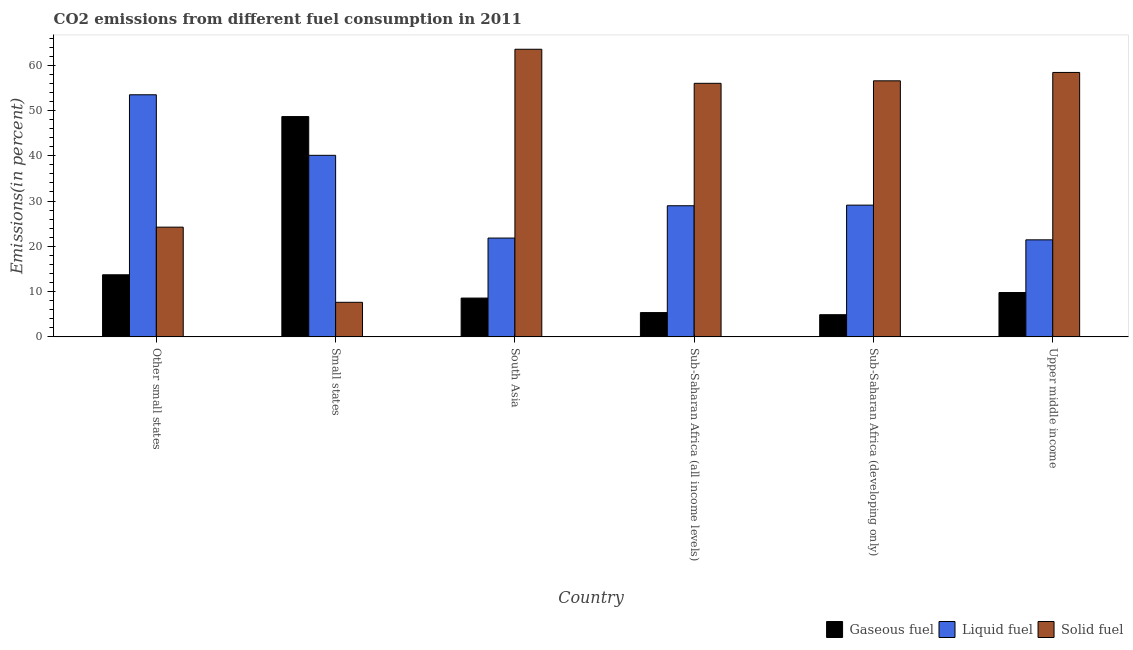How many groups of bars are there?
Your answer should be very brief. 6. Are the number of bars per tick equal to the number of legend labels?
Ensure brevity in your answer.  Yes. What is the label of the 5th group of bars from the left?
Offer a very short reply. Sub-Saharan Africa (developing only). In how many cases, is the number of bars for a given country not equal to the number of legend labels?
Make the answer very short. 0. What is the percentage of solid fuel emission in Small states?
Your answer should be very brief. 7.64. Across all countries, what is the maximum percentage of gaseous fuel emission?
Ensure brevity in your answer.  48.66. Across all countries, what is the minimum percentage of gaseous fuel emission?
Offer a very short reply. 4.9. In which country was the percentage of liquid fuel emission maximum?
Your answer should be compact. Other small states. In which country was the percentage of liquid fuel emission minimum?
Provide a short and direct response. Upper middle income. What is the total percentage of solid fuel emission in the graph?
Your answer should be very brief. 266.35. What is the difference between the percentage of gaseous fuel emission in Small states and that in Upper middle income?
Ensure brevity in your answer.  38.86. What is the difference between the percentage of gaseous fuel emission in Small states and the percentage of liquid fuel emission in South Asia?
Provide a succinct answer. 26.83. What is the average percentage of liquid fuel emission per country?
Offer a very short reply. 32.48. What is the difference between the percentage of gaseous fuel emission and percentage of solid fuel emission in Sub-Saharan Africa (all income levels)?
Keep it short and to the point. -50.63. In how many countries, is the percentage of solid fuel emission greater than 24 %?
Ensure brevity in your answer.  5. What is the ratio of the percentage of solid fuel emission in Other small states to that in South Asia?
Your response must be concise. 0.38. Is the percentage of gaseous fuel emission in Small states less than that in Upper middle income?
Offer a very short reply. No. What is the difference between the highest and the second highest percentage of gaseous fuel emission?
Make the answer very short. 34.95. What is the difference between the highest and the lowest percentage of liquid fuel emission?
Make the answer very short. 32.04. In how many countries, is the percentage of solid fuel emission greater than the average percentage of solid fuel emission taken over all countries?
Your response must be concise. 4. Is the sum of the percentage of gaseous fuel emission in South Asia and Upper middle income greater than the maximum percentage of liquid fuel emission across all countries?
Provide a succinct answer. No. What does the 3rd bar from the left in South Asia represents?
Your answer should be very brief. Solid fuel. What does the 1st bar from the right in Upper middle income represents?
Your response must be concise. Solid fuel. Is it the case that in every country, the sum of the percentage of gaseous fuel emission and percentage of liquid fuel emission is greater than the percentage of solid fuel emission?
Make the answer very short. No. How many bars are there?
Your response must be concise. 18. How many countries are there in the graph?
Your response must be concise. 6. What is the difference between two consecutive major ticks on the Y-axis?
Your response must be concise. 10. Are the values on the major ticks of Y-axis written in scientific E-notation?
Offer a terse response. No. Where does the legend appear in the graph?
Provide a succinct answer. Bottom right. How many legend labels are there?
Offer a terse response. 3. What is the title of the graph?
Your answer should be very brief. CO2 emissions from different fuel consumption in 2011. What is the label or title of the X-axis?
Your response must be concise. Country. What is the label or title of the Y-axis?
Your answer should be compact. Emissions(in percent). What is the Emissions(in percent) of Gaseous fuel in Other small states?
Ensure brevity in your answer.  13.71. What is the Emissions(in percent) in Liquid fuel in Other small states?
Your response must be concise. 53.47. What is the Emissions(in percent) in Solid fuel in Other small states?
Make the answer very short. 24.24. What is the Emissions(in percent) of Gaseous fuel in Small states?
Make the answer very short. 48.66. What is the Emissions(in percent) of Liquid fuel in Small states?
Your answer should be very brief. 40.1. What is the Emissions(in percent) in Solid fuel in Small states?
Provide a succinct answer. 7.64. What is the Emissions(in percent) of Gaseous fuel in South Asia?
Keep it short and to the point. 8.57. What is the Emissions(in percent) in Liquid fuel in South Asia?
Provide a succinct answer. 21.82. What is the Emissions(in percent) of Solid fuel in South Asia?
Make the answer very short. 63.53. What is the Emissions(in percent) of Gaseous fuel in Sub-Saharan Africa (all income levels)?
Make the answer very short. 5.37. What is the Emissions(in percent) in Liquid fuel in Sub-Saharan Africa (all income levels)?
Make the answer very short. 28.96. What is the Emissions(in percent) in Solid fuel in Sub-Saharan Africa (all income levels)?
Offer a very short reply. 56. What is the Emissions(in percent) in Gaseous fuel in Sub-Saharan Africa (developing only)?
Provide a short and direct response. 4.9. What is the Emissions(in percent) in Liquid fuel in Sub-Saharan Africa (developing only)?
Provide a succinct answer. 29.1. What is the Emissions(in percent) in Solid fuel in Sub-Saharan Africa (developing only)?
Your answer should be compact. 56.55. What is the Emissions(in percent) of Gaseous fuel in Upper middle income?
Offer a very short reply. 9.8. What is the Emissions(in percent) of Liquid fuel in Upper middle income?
Provide a short and direct response. 21.43. What is the Emissions(in percent) in Solid fuel in Upper middle income?
Give a very brief answer. 58.4. Across all countries, what is the maximum Emissions(in percent) of Gaseous fuel?
Make the answer very short. 48.66. Across all countries, what is the maximum Emissions(in percent) of Liquid fuel?
Your response must be concise. 53.47. Across all countries, what is the maximum Emissions(in percent) in Solid fuel?
Your answer should be compact. 63.53. Across all countries, what is the minimum Emissions(in percent) of Gaseous fuel?
Offer a very short reply. 4.9. Across all countries, what is the minimum Emissions(in percent) of Liquid fuel?
Your answer should be very brief. 21.43. Across all countries, what is the minimum Emissions(in percent) of Solid fuel?
Give a very brief answer. 7.64. What is the total Emissions(in percent) in Gaseous fuel in the graph?
Your response must be concise. 91. What is the total Emissions(in percent) of Liquid fuel in the graph?
Your response must be concise. 194.88. What is the total Emissions(in percent) of Solid fuel in the graph?
Your answer should be compact. 266.35. What is the difference between the Emissions(in percent) of Gaseous fuel in Other small states and that in Small states?
Your answer should be compact. -34.95. What is the difference between the Emissions(in percent) in Liquid fuel in Other small states and that in Small states?
Provide a succinct answer. 13.37. What is the difference between the Emissions(in percent) of Solid fuel in Other small states and that in Small states?
Make the answer very short. 16.6. What is the difference between the Emissions(in percent) of Gaseous fuel in Other small states and that in South Asia?
Your response must be concise. 5.14. What is the difference between the Emissions(in percent) in Liquid fuel in Other small states and that in South Asia?
Keep it short and to the point. 31.65. What is the difference between the Emissions(in percent) in Solid fuel in Other small states and that in South Asia?
Your answer should be compact. -39.29. What is the difference between the Emissions(in percent) of Gaseous fuel in Other small states and that in Sub-Saharan Africa (all income levels)?
Ensure brevity in your answer.  8.34. What is the difference between the Emissions(in percent) in Liquid fuel in Other small states and that in Sub-Saharan Africa (all income levels)?
Provide a short and direct response. 24.51. What is the difference between the Emissions(in percent) of Solid fuel in Other small states and that in Sub-Saharan Africa (all income levels)?
Your answer should be very brief. -31.77. What is the difference between the Emissions(in percent) of Gaseous fuel in Other small states and that in Sub-Saharan Africa (developing only)?
Provide a succinct answer. 8.82. What is the difference between the Emissions(in percent) of Liquid fuel in Other small states and that in Sub-Saharan Africa (developing only)?
Give a very brief answer. 24.38. What is the difference between the Emissions(in percent) in Solid fuel in Other small states and that in Sub-Saharan Africa (developing only)?
Offer a very short reply. -32.32. What is the difference between the Emissions(in percent) of Gaseous fuel in Other small states and that in Upper middle income?
Provide a short and direct response. 3.92. What is the difference between the Emissions(in percent) in Liquid fuel in Other small states and that in Upper middle income?
Provide a succinct answer. 32.04. What is the difference between the Emissions(in percent) in Solid fuel in Other small states and that in Upper middle income?
Your response must be concise. -34.17. What is the difference between the Emissions(in percent) in Gaseous fuel in Small states and that in South Asia?
Your response must be concise. 40.09. What is the difference between the Emissions(in percent) in Liquid fuel in Small states and that in South Asia?
Offer a terse response. 18.27. What is the difference between the Emissions(in percent) of Solid fuel in Small states and that in South Asia?
Offer a terse response. -55.89. What is the difference between the Emissions(in percent) in Gaseous fuel in Small states and that in Sub-Saharan Africa (all income levels)?
Your answer should be very brief. 43.29. What is the difference between the Emissions(in percent) of Liquid fuel in Small states and that in Sub-Saharan Africa (all income levels)?
Provide a succinct answer. 11.14. What is the difference between the Emissions(in percent) of Solid fuel in Small states and that in Sub-Saharan Africa (all income levels)?
Offer a very short reply. -48.37. What is the difference between the Emissions(in percent) in Gaseous fuel in Small states and that in Sub-Saharan Africa (developing only)?
Ensure brevity in your answer.  43.76. What is the difference between the Emissions(in percent) of Liquid fuel in Small states and that in Sub-Saharan Africa (developing only)?
Provide a short and direct response. 11. What is the difference between the Emissions(in percent) in Solid fuel in Small states and that in Sub-Saharan Africa (developing only)?
Offer a terse response. -48.92. What is the difference between the Emissions(in percent) of Gaseous fuel in Small states and that in Upper middle income?
Your answer should be compact. 38.86. What is the difference between the Emissions(in percent) in Liquid fuel in Small states and that in Upper middle income?
Offer a terse response. 18.67. What is the difference between the Emissions(in percent) of Solid fuel in Small states and that in Upper middle income?
Your response must be concise. -50.77. What is the difference between the Emissions(in percent) of Gaseous fuel in South Asia and that in Sub-Saharan Africa (all income levels)?
Provide a succinct answer. 3.2. What is the difference between the Emissions(in percent) of Liquid fuel in South Asia and that in Sub-Saharan Africa (all income levels)?
Keep it short and to the point. -7.14. What is the difference between the Emissions(in percent) in Solid fuel in South Asia and that in Sub-Saharan Africa (all income levels)?
Your answer should be very brief. 7.52. What is the difference between the Emissions(in percent) of Gaseous fuel in South Asia and that in Sub-Saharan Africa (developing only)?
Your response must be concise. 3.67. What is the difference between the Emissions(in percent) in Liquid fuel in South Asia and that in Sub-Saharan Africa (developing only)?
Provide a succinct answer. -7.27. What is the difference between the Emissions(in percent) of Solid fuel in South Asia and that in Sub-Saharan Africa (developing only)?
Your answer should be very brief. 6.97. What is the difference between the Emissions(in percent) of Gaseous fuel in South Asia and that in Upper middle income?
Keep it short and to the point. -1.23. What is the difference between the Emissions(in percent) of Liquid fuel in South Asia and that in Upper middle income?
Offer a terse response. 0.39. What is the difference between the Emissions(in percent) of Solid fuel in South Asia and that in Upper middle income?
Make the answer very short. 5.12. What is the difference between the Emissions(in percent) in Gaseous fuel in Sub-Saharan Africa (all income levels) and that in Sub-Saharan Africa (developing only)?
Keep it short and to the point. 0.47. What is the difference between the Emissions(in percent) of Liquid fuel in Sub-Saharan Africa (all income levels) and that in Sub-Saharan Africa (developing only)?
Provide a succinct answer. -0.13. What is the difference between the Emissions(in percent) in Solid fuel in Sub-Saharan Africa (all income levels) and that in Sub-Saharan Africa (developing only)?
Your answer should be very brief. -0.55. What is the difference between the Emissions(in percent) of Gaseous fuel in Sub-Saharan Africa (all income levels) and that in Upper middle income?
Make the answer very short. -4.43. What is the difference between the Emissions(in percent) in Liquid fuel in Sub-Saharan Africa (all income levels) and that in Upper middle income?
Offer a very short reply. 7.53. What is the difference between the Emissions(in percent) in Solid fuel in Sub-Saharan Africa (all income levels) and that in Upper middle income?
Your answer should be compact. -2.4. What is the difference between the Emissions(in percent) in Gaseous fuel in Sub-Saharan Africa (developing only) and that in Upper middle income?
Ensure brevity in your answer.  -4.9. What is the difference between the Emissions(in percent) in Liquid fuel in Sub-Saharan Africa (developing only) and that in Upper middle income?
Your answer should be very brief. 7.66. What is the difference between the Emissions(in percent) of Solid fuel in Sub-Saharan Africa (developing only) and that in Upper middle income?
Offer a terse response. -1.85. What is the difference between the Emissions(in percent) in Gaseous fuel in Other small states and the Emissions(in percent) in Liquid fuel in Small states?
Offer a terse response. -26.39. What is the difference between the Emissions(in percent) in Gaseous fuel in Other small states and the Emissions(in percent) in Solid fuel in Small states?
Make the answer very short. 6.08. What is the difference between the Emissions(in percent) of Liquid fuel in Other small states and the Emissions(in percent) of Solid fuel in Small states?
Ensure brevity in your answer.  45.84. What is the difference between the Emissions(in percent) of Gaseous fuel in Other small states and the Emissions(in percent) of Liquid fuel in South Asia?
Your answer should be compact. -8.11. What is the difference between the Emissions(in percent) of Gaseous fuel in Other small states and the Emissions(in percent) of Solid fuel in South Asia?
Provide a short and direct response. -49.81. What is the difference between the Emissions(in percent) in Liquid fuel in Other small states and the Emissions(in percent) in Solid fuel in South Asia?
Provide a succinct answer. -10.05. What is the difference between the Emissions(in percent) of Gaseous fuel in Other small states and the Emissions(in percent) of Liquid fuel in Sub-Saharan Africa (all income levels)?
Your answer should be very brief. -15.25. What is the difference between the Emissions(in percent) of Gaseous fuel in Other small states and the Emissions(in percent) of Solid fuel in Sub-Saharan Africa (all income levels)?
Offer a terse response. -42.29. What is the difference between the Emissions(in percent) in Liquid fuel in Other small states and the Emissions(in percent) in Solid fuel in Sub-Saharan Africa (all income levels)?
Your answer should be very brief. -2.53. What is the difference between the Emissions(in percent) of Gaseous fuel in Other small states and the Emissions(in percent) of Liquid fuel in Sub-Saharan Africa (developing only)?
Your answer should be very brief. -15.38. What is the difference between the Emissions(in percent) of Gaseous fuel in Other small states and the Emissions(in percent) of Solid fuel in Sub-Saharan Africa (developing only)?
Provide a succinct answer. -42.84. What is the difference between the Emissions(in percent) in Liquid fuel in Other small states and the Emissions(in percent) in Solid fuel in Sub-Saharan Africa (developing only)?
Give a very brief answer. -3.08. What is the difference between the Emissions(in percent) of Gaseous fuel in Other small states and the Emissions(in percent) of Liquid fuel in Upper middle income?
Provide a short and direct response. -7.72. What is the difference between the Emissions(in percent) of Gaseous fuel in Other small states and the Emissions(in percent) of Solid fuel in Upper middle income?
Ensure brevity in your answer.  -44.69. What is the difference between the Emissions(in percent) of Liquid fuel in Other small states and the Emissions(in percent) of Solid fuel in Upper middle income?
Give a very brief answer. -4.93. What is the difference between the Emissions(in percent) in Gaseous fuel in Small states and the Emissions(in percent) in Liquid fuel in South Asia?
Ensure brevity in your answer.  26.83. What is the difference between the Emissions(in percent) of Gaseous fuel in Small states and the Emissions(in percent) of Solid fuel in South Asia?
Keep it short and to the point. -14.87. What is the difference between the Emissions(in percent) of Liquid fuel in Small states and the Emissions(in percent) of Solid fuel in South Asia?
Offer a very short reply. -23.43. What is the difference between the Emissions(in percent) of Gaseous fuel in Small states and the Emissions(in percent) of Liquid fuel in Sub-Saharan Africa (all income levels)?
Offer a very short reply. 19.7. What is the difference between the Emissions(in percent) of Gaseous fuel in Small states and the Emissions(in percent) of Solid fuel in Sub-Saharan Africa (all income levels)?
Provide a succinct answer. -7.34. What is the difference between the Emissions(in percent) of Liquid fuel in Small states and the Emissions(in percent) of Solid fuel in Sub-Saharan Africa (all income levels)?
Provide a succinct answer. -15.9. What is the difference between the Emissions(in percent) of Gaseous fuel in Small states and the Emissions(in percent) of Liquid fuel in Sub-Saharan Africa (developing only)?
Your answer should be very brief. 19.56. What is the difference between the Emissions(in percent) in Gaseous fuel in Small states and the Emissions(in percent) in Solid fuel in Sub-Saharan Africa (developing only)?
Your answer should be compact. -7.89. What is the difference between the Emissions(in percent) in Liquid fuel in Small states and the Emissions(in percent) in Solid fuel in Sub-Saharan Africa (developing only)?
Provide a succinct answer. -16.45. What is the difference between the Emissions(in percent) of Gaseous fuel in Small states and the Emissions(in percent) of Liquid fuel in Upper middle income?
Make the answer very short. 27.23. What is the difference between the Emissions(in percent) in Gaseous fuel in Small states and the Emissions(in percent) in Solid fuel in Upper middle income?
Offer a terse response. -9.74. What is the difference between the Emissions(in percent) in Liquid fuel in Small states and the Emissions(in percent) in Solid fuel in Upper middle income?
Give a very brief answer. -18.3. What is the difference between the Emissions(in percent) of Gaseous fuel in South Asia and the Emissions(in percent) of Liquid fuel in Sub-Saharan Africa (all income levels)?
Keep it short and to the point. -20.39. What is the difference between the Emissions(in percent) of Gaseous fuel in South Asia and the Emissions(in percent) of Solid fuel in Sub-Saharan Africa (all income levels)?
Offer a very short reply. -47.43. What is the difference between the Emissions(in percent) of Liquid fuel in South Asia and the Emissions(in percent) of Solid fuel in Sub-Saharan Africa (all income levels)?
Offer a terse response. -34.18. What is the difference between the Emissions(in percent) in Gaseous fuel in South Asia and the Emissions(in percent) in Liquid fuel in Sub-Saharan Africa (developing only)?
Make the answer very short. -20.53. What is the difference between the Emissions(in percent) of Gaseous fuel in South Asia and the Emissions(in percent) of Solid fuel in Sub-Saharan Africa (developing only)?
Offer a terse response. -47.98. What is the difference between the Emissions(in percent) in Liquid fuel in South Asia and the Emissions(in percent) in Solid fuel in Sub-Saharan Africa (developing only)?
Your answer should be compact. -34.73. What is the difference between the Emissions(in percent) of Gaseous fuel in South Asia and the Emissions(in percent) of Liquid fuel in Upper middle income?
Provide a succinct answer. -12.86. What is the difference between the Emissions(in percent) of Gaseous fuel in South Asia and the Emissions(in percent) of Solid fuel in Upper middle income?
Your answer should be very brief. -49.83. What is the difference between the Emissions(in percent) in Liquid fuel in South Asia and the Emissions(in percent) in Solid fuel in Upper middle income?
Provide a short and direct response. -36.58. What is the difference between the Emissions(in percent) of Gaseous fuel in Sub-Saharan Africa (all income levels) and the Emissions(in percent) of Liquid fuel in Sub-Saharan Africa (developing only)?
Offer a very short reply. -23.73. What is the difference between the Emissions(in percent) of Gaseous fuel in Sub-Saharan Africa (all income levels) and the Emissions(in percent) of Solid fuel in Sub-Saharan Africa (developing only)?
Offer a terse response. -51.18. What is the difference between the Emissions(in percent) in Liquid fuel in Sub-Saharan Africa (all income levels) and the Emissions(in percent) in Solid fuel in Sub-Saharan Africa (developing only)?
Offer a very short reply. -27.59. What is the difference between the Emissions(in percent) in Gaseous fuel in Sub-Saharan Africa (all income levels) and the Emissions(in percent) in Liquid fuel in Upper middle income?
Give a very brief answer. -16.06. What is the difference between the Emissions(in percent) of Gaseous fuel in Sub-Saharan Africa (all income levels) and the Emissions(in percent) of Solid fuel in Upper middle income?
Keep it short and to the point. -53.03. What is the difference between the Emissions(in percent) of Liquid fuel in Sub-Saharan Africa (all income levels) and the Emissions(in percent) of Solid fuel in Upper middle income?
Your answer should be very brief. -29.44. What is the difference between the Emissions(in percent) in Gaseous fuel in Sub-Saharan Africa (developing only) and the Emissions(in percent) in Liquid fuel in Upper middle income?
Give a very brief answer. -16.53. What is the difference between the Emissions(in percent) in Gaseous fuel in Sub-Saharan Africa (developing only) and the Emissions(in percent) in Solid fuel in Upper middle income?
Provide a short and direct response. -53.5. What is the difference between the Emissions(in percent) of Liquid fuel in Sub-Saharan Africa (developing only) and the Emissions(in percent) of Solid fuel in Upper middle income?
Offer a terse response. -29.31. What is the average Emissions(in percent) of Gaseous fuel per country?
Offer a terse response. 15.17. What is the average Emissions(in percent) of Liquid fuel per country?
Your response must be concise. 32.48. What is the average Emissions(in percent) in Solid fuel per country?
Your answer should be compact. 44.39. What is the difference between the Emissions(in percent) of Gaseous fuel and Emissions(in percent) of Liquid fuel in Other small states?
Give a very brief answer. -39.76. What is the difference between the Emissions(in percent) in Gaseous fuel and Emissions(in percent) in Solid fuel in Other small states?
Ensure brevity in your answer.  -10.52. What is the difference between the Emissions(in percent) in Liquid fuel and Emissions(in percent) in Solid fuel in Other small states?
Provide a short and direct response. 29.24. What is the difference between the Emissions(in percent) in Gaseous fuel and Emissions(in percent) in Liquid fuel in Small states?
Keep it short and to the point. 8.56. What is the difference between the Emissions(in percent) in Gaseous fuel and Emissions(in percent) in Solid fuel in Small states?
Provide a short and direct response. 41.02. What is the difference between the Emissions(in percent) in Liquid fuel and Emissions(in percent) in Solid fuel in Small states?
Provide a succinct answer. 32.46. What is the difference between the Emissions(in percent) of Gaseous fuel and Emissions(in percent) of Liquid fuel in South Asia?
Offer a very short reply. -13.26. What is the difference between the Emissions(in percent) in Gaseous fuel and Emissions(in percent) in Solid fuel in South Asia?
Give a very brief answer. -54.96. What is the difference between the Emissions(in percent) of Liquid fuel and Emissions(in percent) of Solid fuel in South Asia?
Offer a very short reply. -41.7. What is the difference between the Emissions(in percent) in Gaseous fuel and Emissions(in percent) in Liquid fuel in Sub-Saharan Africa (all income levels)?
Make the answer very short. -23.59. What is the difference between the Emissions(in percent) of Gaseous fuel and Emissions(in percent) of Solid fuel in Sub-Saharan Africa (all income levels)?
Offer a very short reply. -50.63. What is the difference between the Emissions(in percent) of Liquid fuel and Emissions(in percent) of Solid fuel in Sub-Saharan Africa (all income levels)?
Your response must be concise. -27.04. What is the difference between the Emissions(in percent) in Gaseous fuel and Emissions(in percent) in Liquid fuel in Sub-Saharan Africa (developing only)?
Ensure brevity in your answer.  -24.2. What is the difference between the Emissions(in percent) of Gaseous fuel and Emissions(in percent) of Solid fuel in Sub-Saharan Africa (developing only)?
Your response must be concise. -51.66. What is the difference between the Emissions(in percent) in Liquid fuel and Emissions(in percent) in Solid fuel in Sub-Saharan Africa (developing only)?
Your answer should be compact. -27.46. What is the difference between the Emissions(in percent) of Gaseous fuel and Emissions(in percent) of Liquid fuel in Upper middle income?
Give a very brief answer. -11.63. What is the difference between the Emissions(in percent) of Gaseous fuel and Emissions(in percent) of Solid fuel in Upper middle income?
Provide a short and direct response. -48.61. What is the difference between the Emissions(in percent) of Liquid fuel and Emissions(in percent) of Solid fuel in Upper middle income?
Ensure brevity in your answer.  -36.97. What is the ratio of the Emissions(in percent) of Gaseous fuel in Other small states to that in Small states?
Offer a terse response. 0.28. What is the ratio of the Emissions(in percent) in Liquid fuel in Other small states to that in Small states?
Provide a short and direct response. 1.33. What is the ratio of the Emissions(in percent) of Solid fuel in Other small states to that in Small states?
Provide a succinct answer. 3.17. What is the ratio of the Emissions(in percent) of Gaseous fuel in Other small states to that in South Asia?
Your answer should be compact. 1.6. What is the ratio of the Emissions(in percent) of Liquid fuel in Other small states to that in South Asia?
Offer a terse response. 2.45. What is the ratio of the Emissions(in percent) of Solid fuel in Other small states to that in South Asia?
Offer a terse response. 0.38. What is the ratio of the Emissions(in percent) in Gaseous fuel in Other small states to that in Sub-Saharan Africa (all income levels)?
Ensure brevity in your answer.  2.55. What is the ratio of the Emissions(in percent) in Liquid fuel in Other small states to that in Sub-Saharan Africa (all income levels)?
Provide a short and direct response. 1.85. What is the ratio of the Emissions(in percent) of Solid fuel in Other small states to that in Sub-Saharan Africa (all income levels)?
Your answer should be compact. 0.43. What is the ratio of the Emissions(in percent) in Gaseous fuel in Other small states to that in Sub-Saharan Africa (developing only)?
Provide a succinct answer. 2.8. What is the ratio of the Emissions(in percent) of Liquid fuel in Other small states to that in Sub-Saharan Africa (developing only)?
Your answer should be compact. 1.84. What is the ratio of the Emissions(in percent) in Solid fuel in Other small states to that in Sub-Saharan Africa (developing only)?
Offer a terse response. 0.43. What is the ratio of the Emissions(in percent) in Gaseous fuel in Other small states to that in Upper middle income?
Give a very brief answer. 1.4. What is the ratio of the Emissions(in percent) of Liquid fuel in Other small states to that in Upper middle income?
Your answer should be very brief. 2.5. What is the ratio of the Emissions(in percent) in Solid fuel in Other small states to that in Upper middle income?
Provide a succinct answer. 0.41. What is the ratio of the Emissions(in percent) in Gaseous fuel in Small states to that in South Asia?
Ensure brevity in your answer.  5.68. What is the ratio of the Emissions(in percent) in Liquid fuel in Small states to that in South Asia?
Your answer should be very brief. 1.84. What is the ratio of the Emissions(in percent) of Solid fuel in Small states to that in South Asia?
Offer a terse response. 0.12. What is the ratio of the Emissions(in percent) in Gaseous fuel in Small states to that in Sub-Saharan Africa (all income levels)?
Provide a succinct answer. 9.06. What is the ratio of the Emissions(in percent) of Liquid fuel in Small states to that in Sub-Saharan Africa (all income levels)?
Provide a short and direct response. 1.38. What is the ratio of the Emissions(in percent) of Solid fuel in Small states to that in Sub-Saharan Africa (all income levels)?
Keep it short and to the point. 0.14. What is the ratio of the Emissions(in percent) of Gaseous fuel in Small states to that in Sub-Saharan Africa (developing only)?
Make the answer very short. 9.94. What is the ratio of the Emissions(in percent) of Liquid fuel in Small states to that in Sub-Saharan Africa (developing only)?
Your answer should be compact. 1.38. What is the ratio of the Emissions(in percent) of Solid fuel in Small states to that in Sub-Saharan Africa (developing only)?
Provide a short and direct response. 0.14. What is the ratio of the Emissions(in percent) in Gaseous fuel in Small states to that in Upper middle income?
Your answer should be compact. 4.97. What is the ratio of the Emissions(in percent) in Liquid fuel in Small states to that in Upper middle income?
Offer a terse response. 1.87. What is the ratio of the Emissions(in percent) in Solid fuel in Small states to that in Upper middle income?
Ensure brevity in your answer.  0.13. What is the ratio of the Emissions(in percent) of Gaseous fuel in South Asia to that in Sub-Saharan Africa (all income levels)?
Your answer should be compact. 1.6. What is the ratio of the Emissions(in percent) of Liquid fuel in South Asia to that in Sub-Saharan Africa (all income levels)?
Offer a terse response. 0.75. What is the ratio of the Emissions(in percent) in Solid fuel in South Asia to that in Sub-Saharan Africa (all income levels)?
Offer a terse response. 1.13. What is the ratio of the Emissions(in percent) of Gaseous fuel in South Asia to that in Sub-Saharan Africa (developing only)?
Provide a short and direct response. 1.75. What is the ratio of the Emissions(in percent) of Liquid fuel in South Asia to that in Sub-Saharan Africa (developing only)?
Make the answer very short. 0.75. What is the ratio of the Emissions(in percent) in Solid fuel in South Asia to that in Sub-Saharan Africa (developing only)?
Give a very brief answer. 1.12. What is the ratio of the Emissions(in percent) in Gaseous fuel in South Asia to that in Upper middle income?
Ensure brevity in your answer.  0.87. What is the ratio of the Emissions(in percent) in Liquid fuel in South Asia to that in Upper middle income?
Offer a terse response. 1.02. What is the ratio of the Emissions(in percent) of Solid fuel in South Asia to that in Upper middle income?
Ensure brevity in your answer.  1.09. What is the ratio of the Emissions(in percent) of Gaseous fuel in Sub-Saharan Africa (all income levels) to that in Sub-Saharan Africa (developing only)?
Offer a very short reply. 1.1. What is the ratio of the Emissions(in percent) in Solid fuel in Sub-Saharan Africa (all income levels) to that in Sub-Saharan Africa (developing only)?
Provide a succinct answer. 0.99. What is the ratio of the Emissions(in percent) of Gaseous fuel in Sub-Saharan Africa (all income levels) to that in Upper middle income?
Your response must be concise. 0.55. What is the ratio of the Emissions(in percent) in Liquid fuel in Sub-Saharan Africa (all income levels) to that in Upper middle income?
Your response must be concise. 1.35. What is the ratio of the Emissions(in percent) of Solid fuel in Sub-Saharan Africa (all income levels) to that in Upper middle income?
Ensure brevity in your answer.  0.96. What is the ratio of the Emissions(in percent) in Gaseous fuel in Sub-Saharan Africa (developing only) to that in Upper middle income?
Keep it short and to the point. 0.5. What is the ratio of the Emissions(in percent) in Liquid fuel in Sub-Saharan Africa (developing only) to that in Upper middle income?
Keep it short and to the point. 1.36. What is the ratio of the Emissions(in percent) of Solid fuel in Sub-Saharan Africa (developing only) to that in Upper middle income?
Provide a succinct answer. 0.97. What is the difference between the highest and the second highest Emissions(in percent) of Gaseous fuel?
Your response must be concise. 34.95. What is the difference between the highest and the second highest Emissions(in percent) in Liquid fuel?
Offer a terse response. 13.37. What is the difference between the highest and the second highest Emissions(in percent) in Solid fuel?
Offer a very short reply. 5.12. What is the difference between the highest and the lowest Emissions(in percent) in Gaseous fuel?
Your answer should be compact. 43.76. What is the difference between the highest and the lowest Emissions(in percent) of Liquid fuel?
Your answer should be compact. 32.04. What is the difference between the highest and the lowest Emissions(in percent) in Solid fuel?
Make the answer very short. 55.89. 